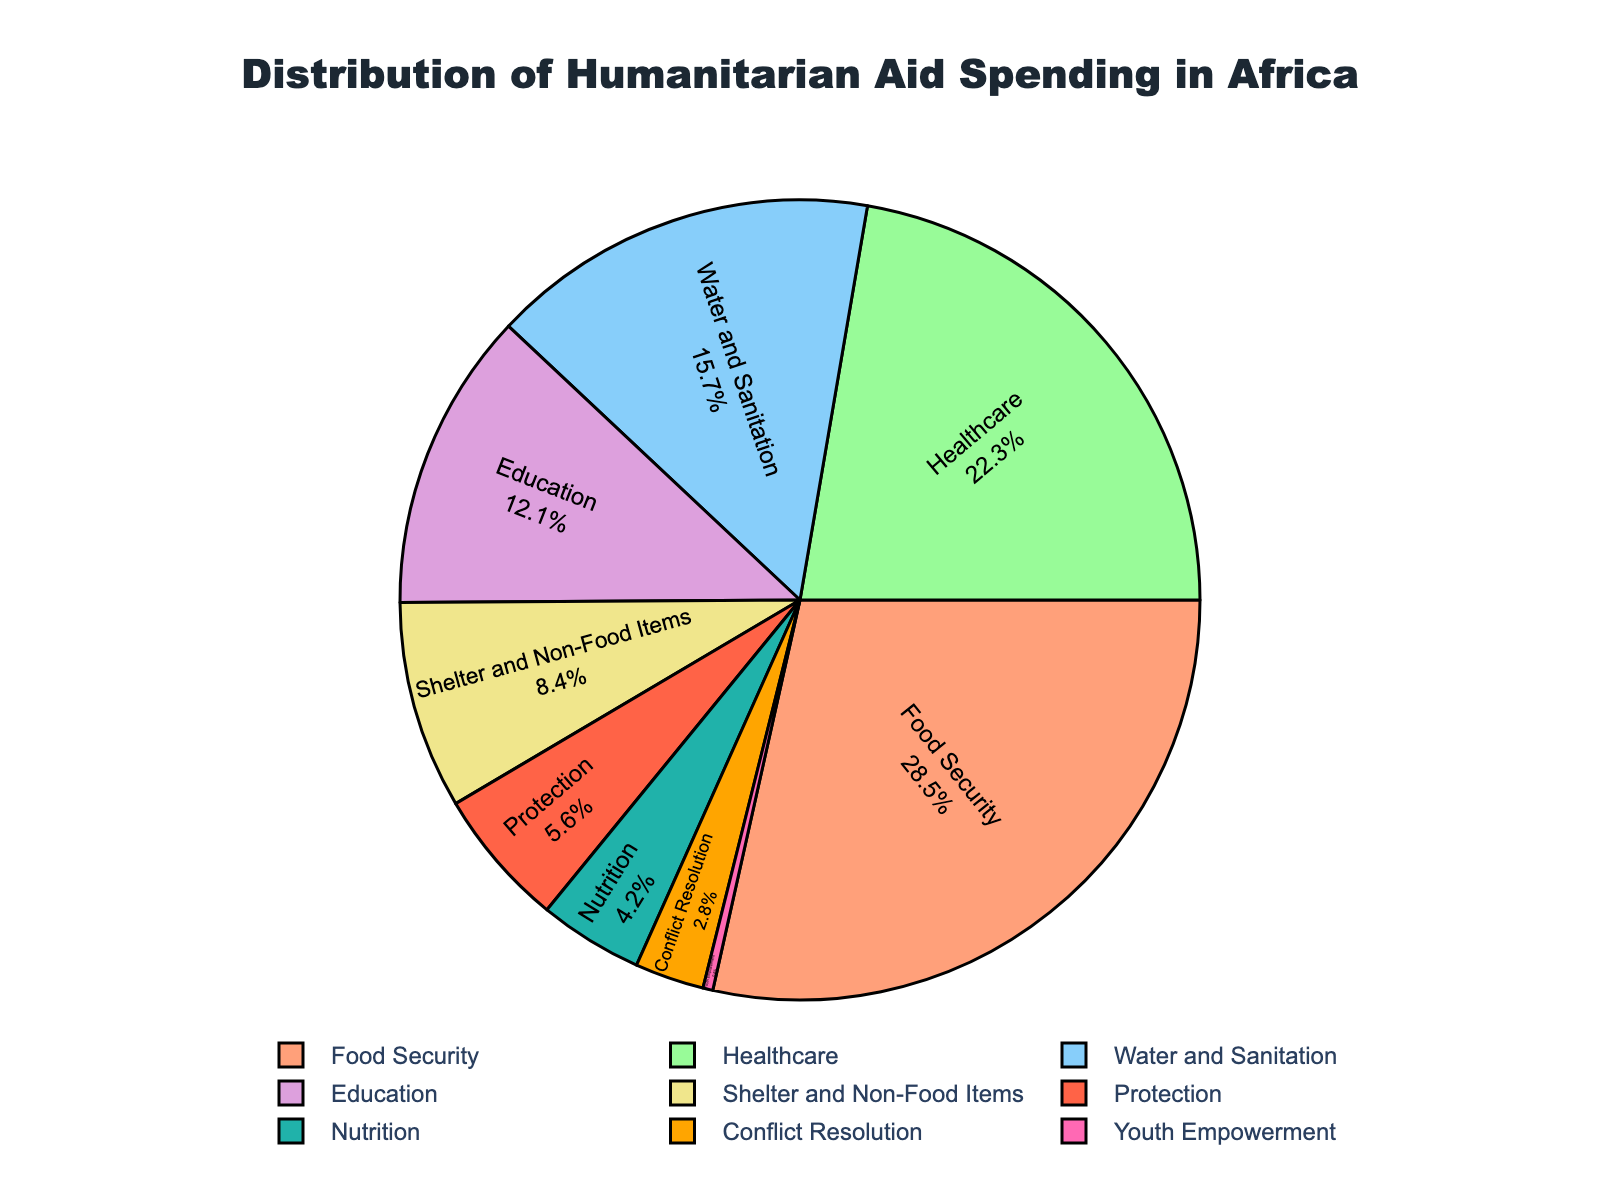Which sector receives the largest share of humanitarian aid funding? By looking at the pie chart, the largest section belongs to Food Security.
Answer: Food Security How much more funding does Healthcare receive compared to Nutrition? Healthcare receives 22.3%, while Nutrition receives 4.2%. The difference is 22.3% - 4.2% = 18.1%.
Answer: 18.1% What percentage of the total aid is allocated to Water and Sanitation and Shelter and Non-Food Items combined? Water and Sanitation has 15.7%, and Shelter and Non-Food Items has 8.4%. Adding these together gives 15.7% + 8.4% = 24.1%.
Answer: 24.1% Which sector receives the least amount of humanitarian aid spending? By observing the smallest section in the pie chart, which belongs to Youth Empowerment.
Answer: Youth Empowerment Is the funding for Education greater than or less than Protection? Education receives 12.1%, and Protection receives 5.6%. 12.1% is greater than 5.6%.
Answer: Greater than Among the sectors listed, what are the top three largest percentages? The three largest sectors, based on their percentages, are Food Security (28.5%), Healthcare (22.3%), and Water and Sanitation (15.7%).
Answer: Food Security, Healthcare, Water and Sanitation How much more percentage does Food Security receive compared to Conflict Resolution and Youth Empowerment combined? Conflict Resolution receives 2.8%, and Youth Empowerment receives 0.4%. Their combined total is 2.8% + 0.4% = 3.2%. Food Security receives 28.5%. The difference is 28.5% - 3.2% = 25.3%.
Answer: 25.3% What is the combined percentage of humanitarian aid allocated to sectors other than Food Security? The total percentage allocated to all sectors is 100%. Subtracting the percentage for Food Security (28.5%) from 100% gives 100% - 28.5% = 71.5%.
Answer: 71.5% 